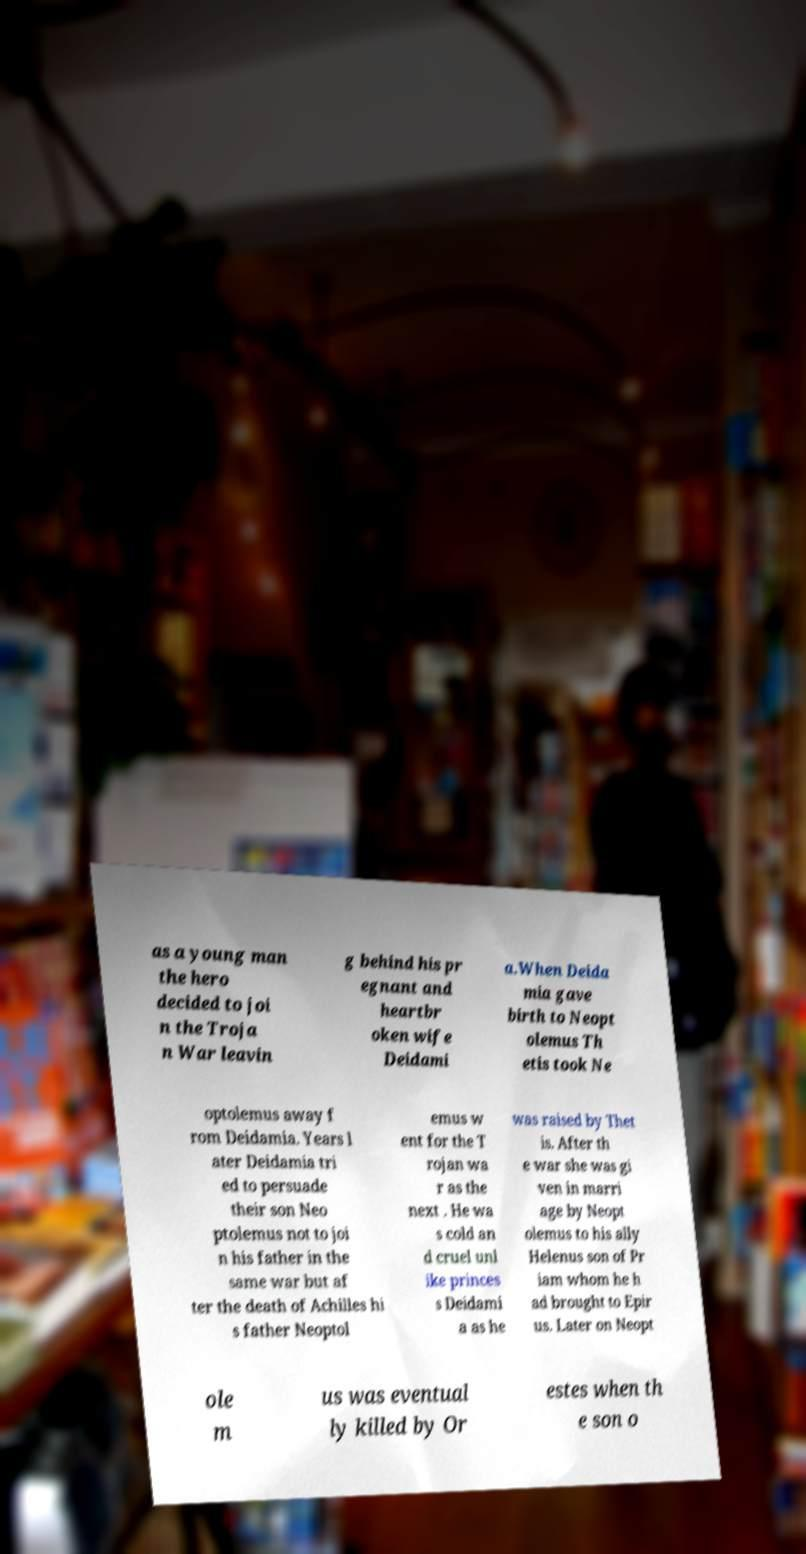Can you accurately transcribe the text from the provided image for me? as a young man the hero decided to joi n the Troja n War leavin g behind his pr egnant and heartbr oken wife Deidami a.When Deida mia gave birth to Neopt olemus Th etis took Ne optolemus away f rom Deidamia. Years l ater Deidamia tri ed to persuade their son Neo ptolemus not to joi n his father in the same war but af ter the death of Achilles hi s father Neoptol emus w ent for the T rojan wa r as the next . He wa s cold an d cruel unl ike princes s Deidami a as he was raised by Thet is. After th e war she was gi ven in marri age by Neopt olemus to his ally Helenus son of Pr iam whom he h ad brought to Epir us. Later on Neopt ole m us was eventual ly killed by Or estes when th e son o 